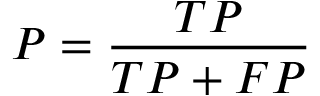Convert formula to latex. <formula><loc_0><loc_0><loc_500><loc_500>P = \frac { T P } { T P + F P }</formula> 